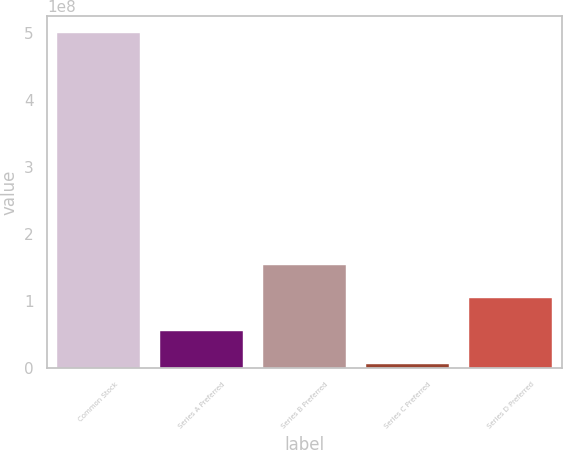<chart> <loc_0><loc_0><loc_500><loc_500><bar_chart><fcel>Common Stock<fcel>Series A Preferred<fcel>Series B Preferred<fcel>Series C Preferred<fcel>Series D Preferred<nl><fcel>5e+08<fcel>5.54e+07<fcel>1.542e+08<fcel>6e+06<fcel>1.048e+08<nl></chart> 